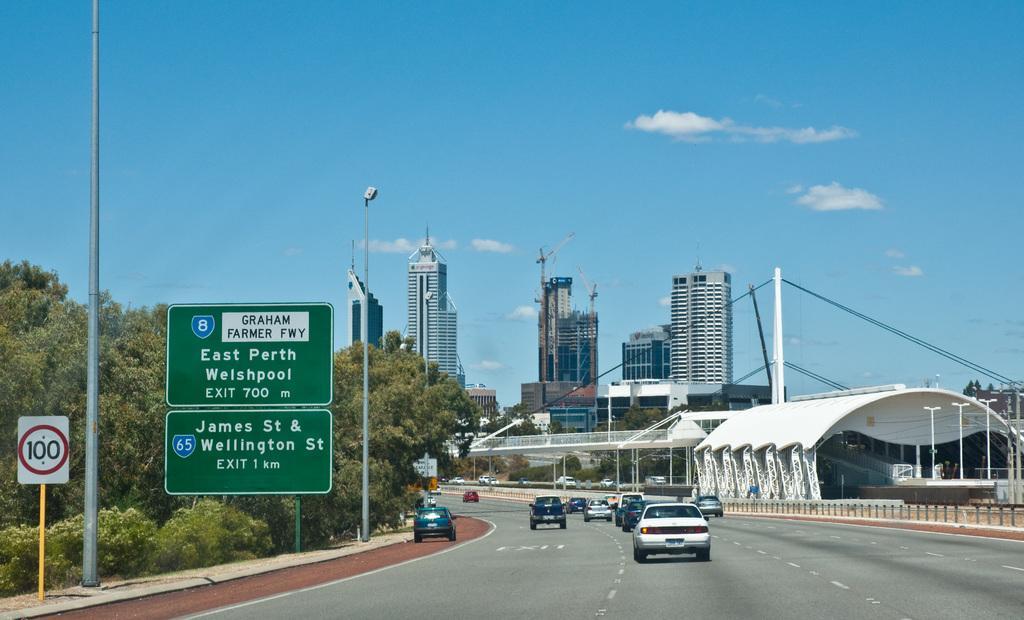Describe this image in one or two sentences. In this image there are few buildings, trees, few vehicles on the road, a curved roof, electric poles, sign boards, a fence and some clouds in the sky. 